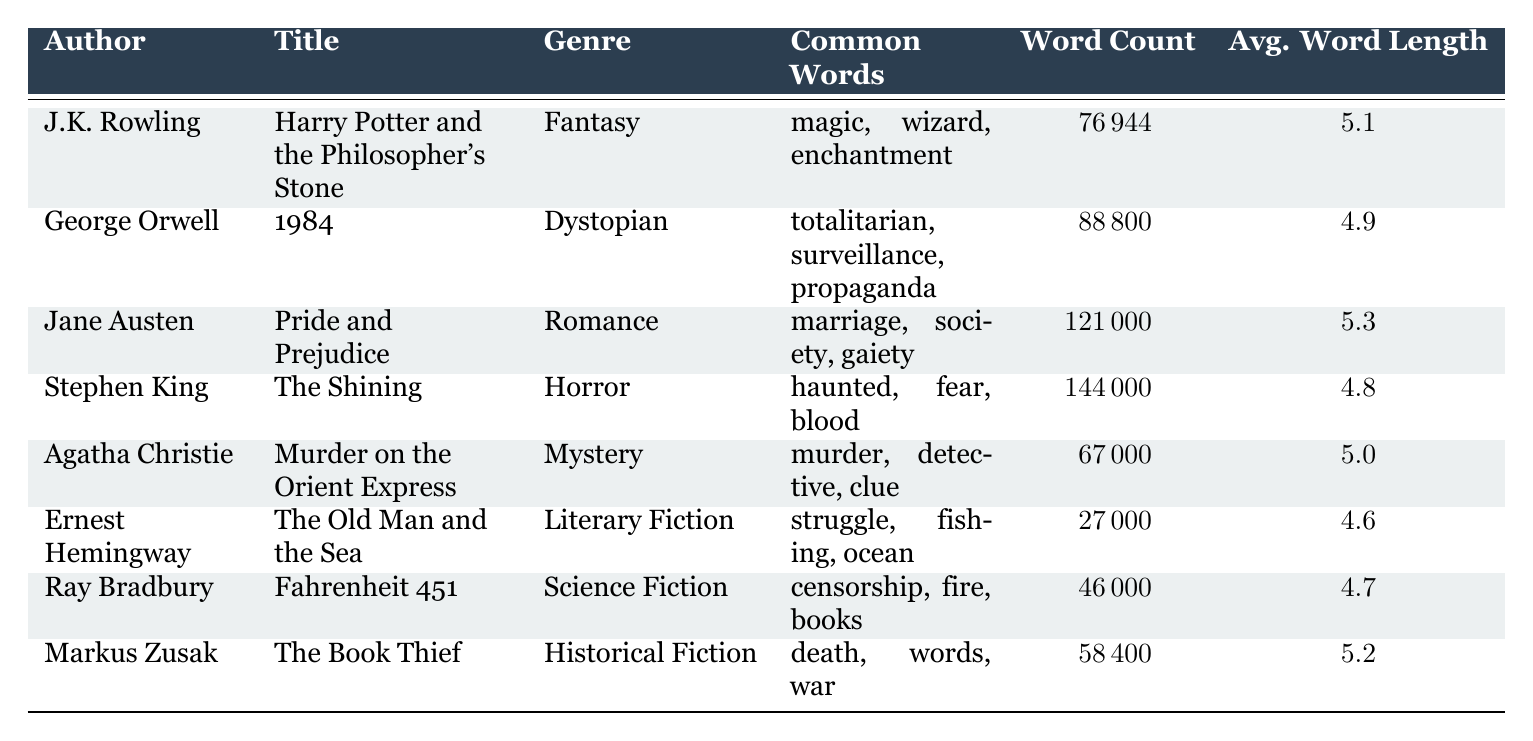What is the genre of "The Old Man and the Sea"? The genre of "The Old Man and the Sea" is listed in the table under the genre column next to the title. It states "Literary Fiction."
Answer: Literary Fiction Which author has written the work with the highest word count? To determine the author with the highest word count, I can look for the maximum value in the word count column and find the corresponding author name. The maximum word count is 144000, which corresponds to Stephen King.
Answer: Stephen King What is the average word length in "Pride and Prejudice"? The average word length for "Pride and Prejudice" is stated directly in the table under the average word length column. It shows the value as 5.3.
Answer: 5.3 Is "1984" categorized under Science Fiction? The genre for "1984" can be found in the genre column of the table. It states "Dystopian," so it is not categorized under Science Fiction.
Answer: No What is the total word count of all works listed in the table? To find the total word count, I need to sum up the word counts found in the table. By adding 76944, 88800, 121000, 144000, 67000, 27000, 46000, and 58400, the total equals 511144.
Answer: 511144 Which genre has the longest average word length and what is that length? I will compare the average word lengths of all genres in the table. The average word lengths are 5.1 (Fantasy), 4.9 (Dystopian), 5.3 (Romance), 4.8 (Horror), 5.0 (Mystery), 4.6 (Literary Fiction), 4.7 (Science Fiction), and 5.2 (Historical Fiction). The longest average word length is 5.3, which corresponds to the Romance genre.
Answer: 5.3, Romance Are there more words on average in "The Shining" compared to "Fahrenheit 451"? The average word lengths for "The Shining" is 4.8 and for "Fahrenheit 451" is 4.7. Since 4.8 is greater than 4.7, "The Shining" has more words on average.
Answer: Yes Which work features common word choices related to "war"? By looking at the common word choices for each title, "The Book Thief" features common words like "death," "words," and "war," indicating it's associated with that theme.
Answer: The Book Thief How many authors have books that have an average word length greater than 5? The authors with an average word length greater than 5 are J.K. Rowling (5.1), Jane Austen (5.3), and Markus Zusak (5.2). Hence, there are 3 authors.
Answer: 3 